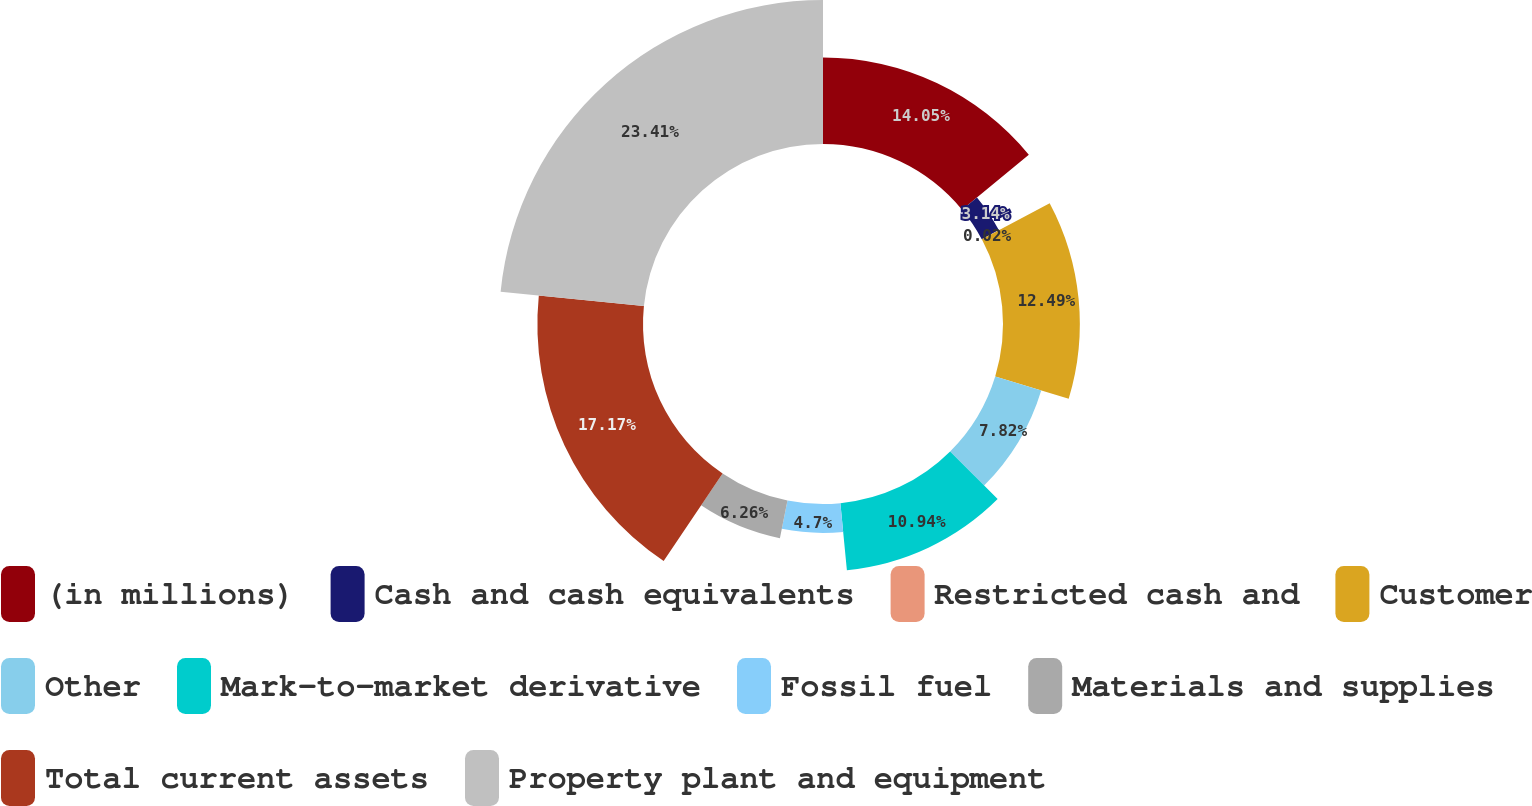Convert chart to OTSL. <chart><loc_0><loc_0><loc_500><loc_500><pie_chart><fcel>(in millions)<fcel>Cash and cash equivalents<fcel>Restricted cash and<fcel>Customer<fcel>Other<fcel>Mark-to-market derivative<fcel>Fossil fuel<fcel>Materials and supplies<fcel>Total current assets<fcel>Property plant and equipment<nl><fcel>14.05%<fcel>3.14%<fcel>0.02%<fcel>12.49%<fcel>7.82%<fcel>10.94%<fcel>4.7%<fcel>6.26%<fcel>17.17%<fcel>23.41%<nl></chart> 